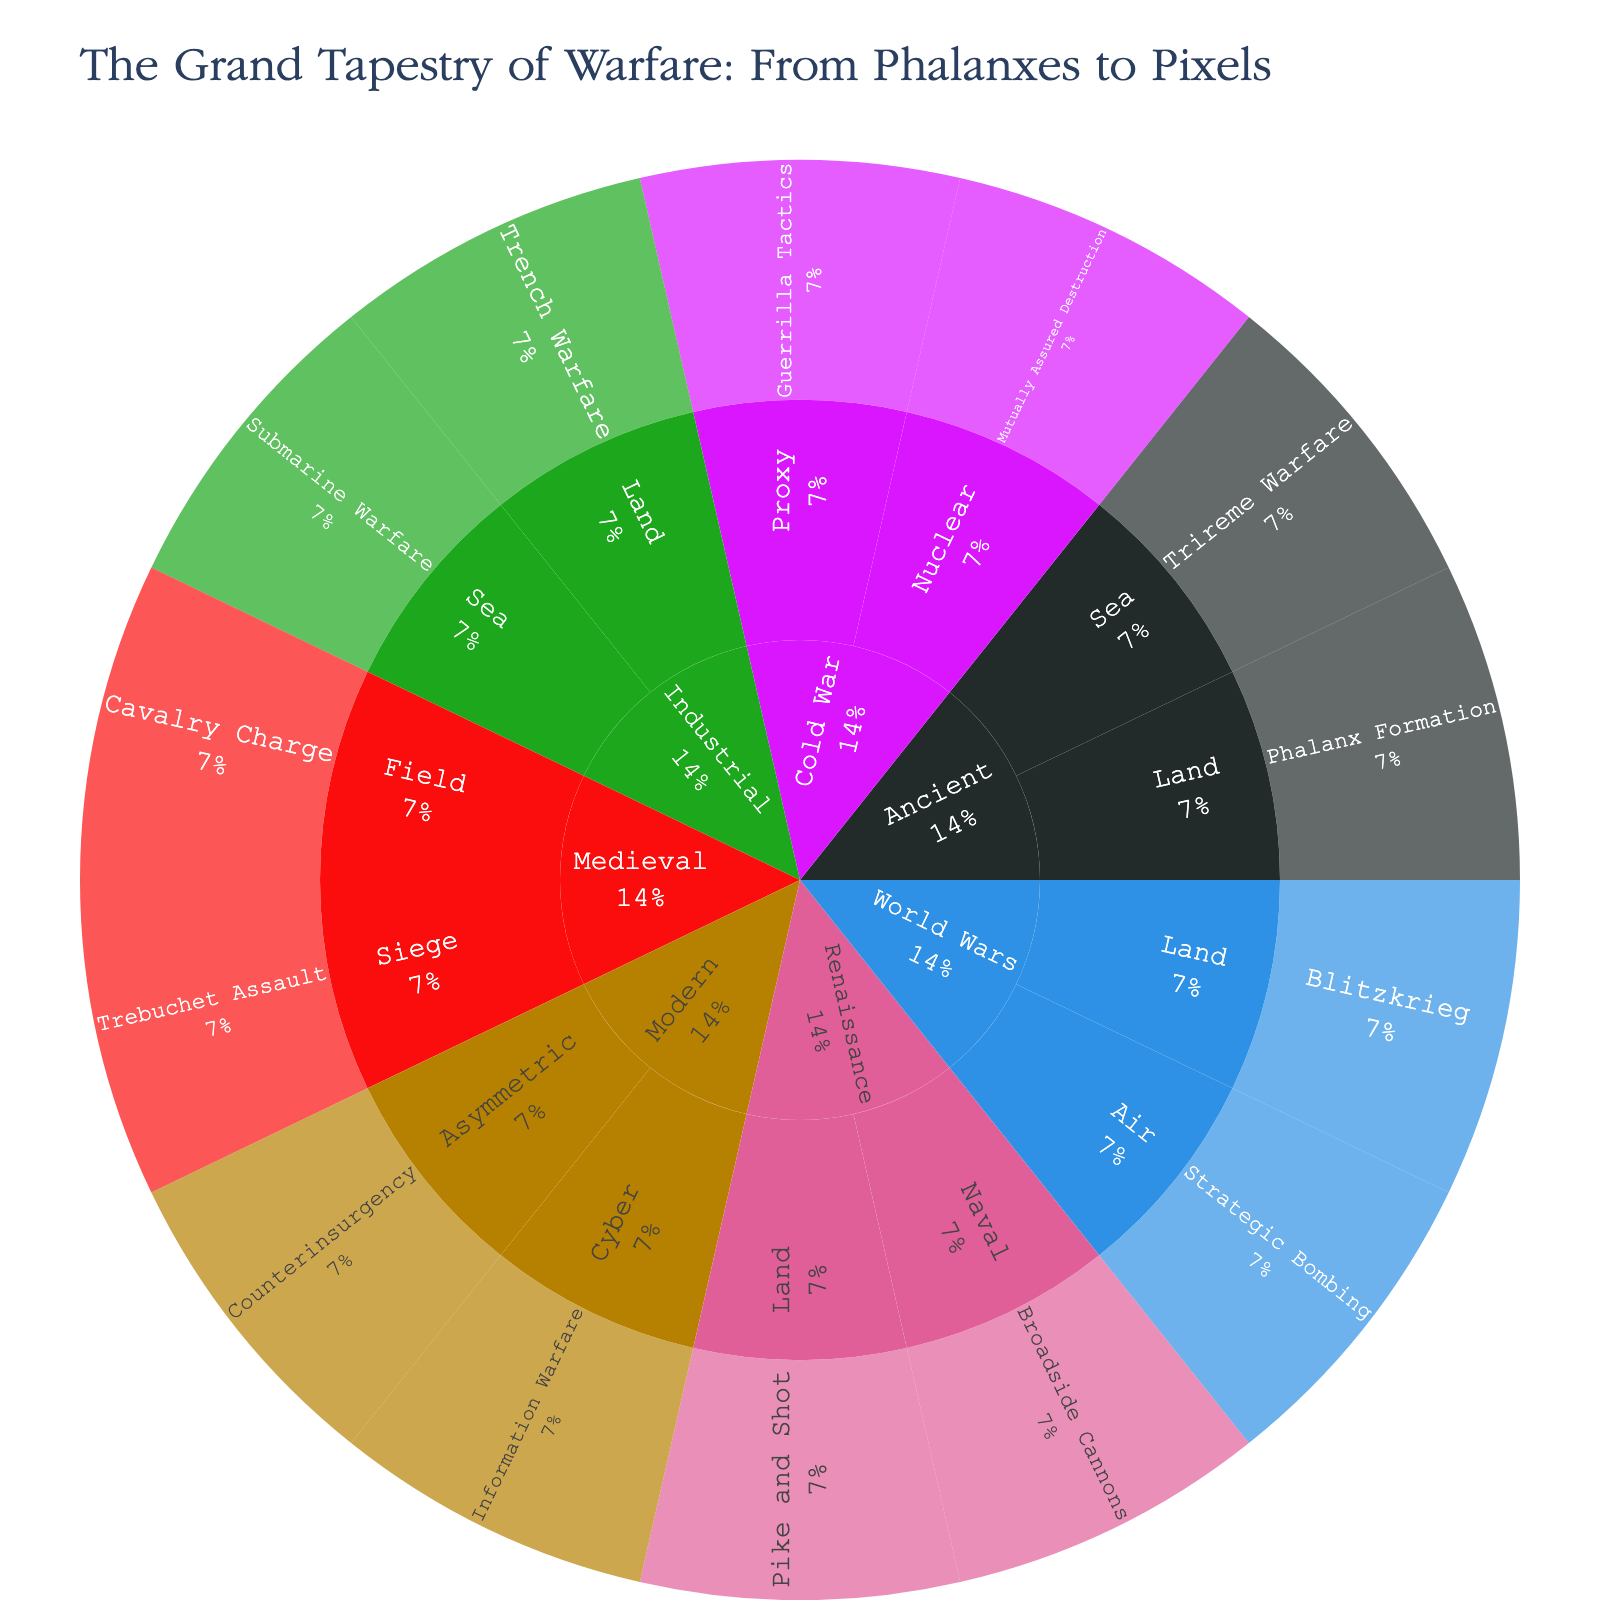What is the title of the sunburst plot? The title can be found at the top center of the sunburst plot. It should be clearly displayed and is typically formatted in a larger or distinct font.
Answer: The Grand Tapestry of Warfare: From Phalanxes to Pixels Which era features "Trebuchet Assault" as a military strategy? By tracing the path through the sunburst plot, "Trebuchet Assault" is nested under "Medieval," indicating that it's part of the Medieval era.
Answer: Medieval What percentage of the total does the "Industrial" era occupy in the plot? Each sector of the sunburst plot represents a percentage of the whole. The "Industrial" era's sector can be read directly off the plot as a percentage of the total.
Answer: (Assuming visualization contains this information) List all the Conflict Types associated with the Cold War era. By identifying the Cold War section of the sunburst plot and examining the nested Conflict Types, we can list all relevant Conflict Types.
Answer: Proxy, Nuclear Does the "Modern" era have more Conflict Types than the "Renaissance" era? If so, how many more? Count the number of Conflict Types under both the Modern and Renaissance eras from the plot and compare the counts.
Answer: Yes, Modern has 4 while Renaissance has 2, so 2 more Which era includes the strategy "Blitzkrieg"? Find the "Blitzkrieg" label within the plot and trace back to the corresponding era.
Answer: World Wars Compare the number of strategies between "Medieval" and "World Wars" eras. Which has more? Count the strategies listed under both the Medieval and World Wars eras and compare the totals.
Answer: Medieval has 2; World Wars has 2; they are equal Is there a strategy related to "Phalanx Formation"? Which era and conflict type does it belong to? Locate "Phalanx Formation" in the plot to see its era and conflict type placement.
Answer: Yes, it belongs to the Ancient era and Land conflict type What description is provided for "Guerrilla Tactics" in the Cold War era? Hover over or locate "Guerrilla Tactics" to read the description provided in the plot.
Answer: Shadows in the jungle Identify the conflict type with the least number of strategies in the sunburst plot. Examine each conflict type within every era, count the number of strategies and identify the one with the least.
Answer: (Answer depends on visualization) 